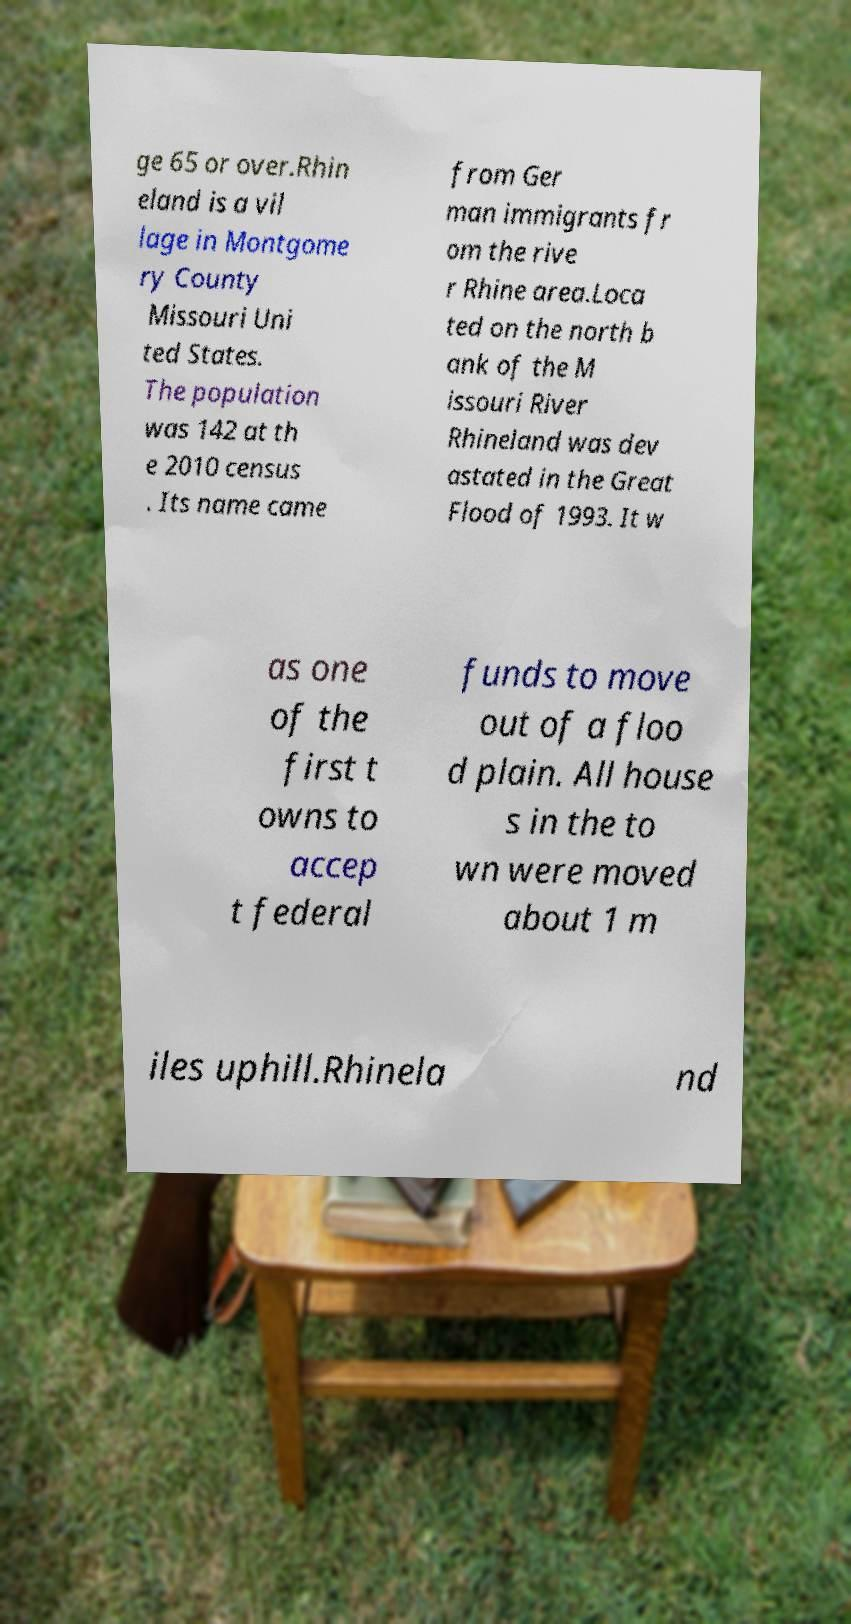Could you assist in decoding the text presented in this image and type it out clearly? ge 65 or over.Rhin eland is a vil lage in Montgome ry County Missouri Uni ted States. The population was 142 at th e 2010 census . Its name came from Ger man immigrants fr om the rive r Rhine area.Loca ted on the north b ank of the M issouri River Rhineland was dev astated in the Great Flood of 1993. It w as one of the first t owns to accep t federal funds to move out of a floo d plain. All house s in the to wn were moved about 1 m iles uphill.Rhinela nd 